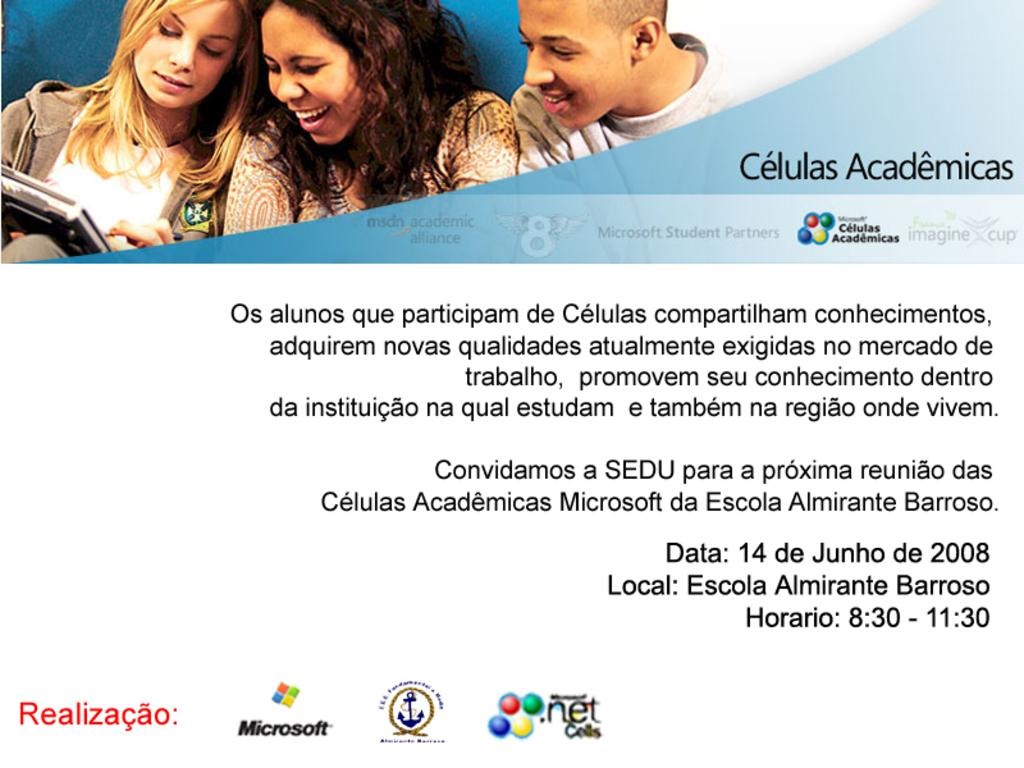How many people are in the image? There are three people in the image. What expression do the people have in the image? The people are smiling in the image. What can be seen in the image besides the people? There is a device, symbols, and some text visible in the image. What type of cap is the dog wearing in the image? There is no dog present in the image, and therefore no cap or any other accessory can be observed on a dog. 